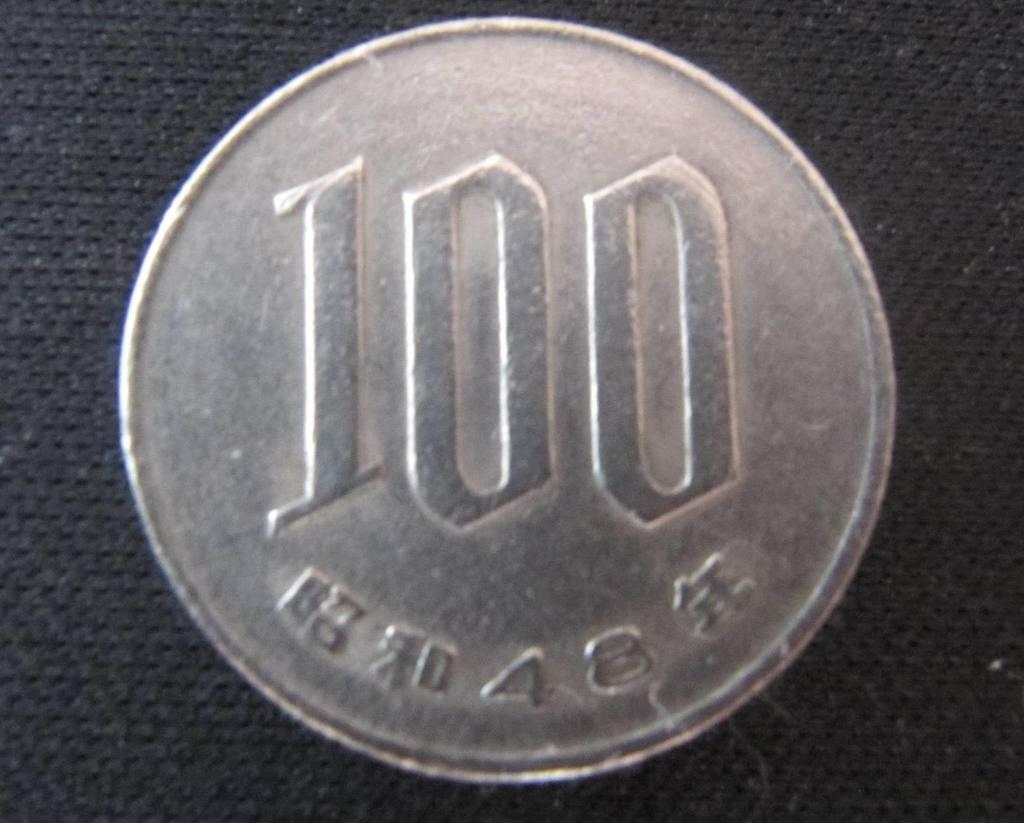<image>
Create a compact narrative representing the image presented. a silver coin with 100 written largely across the middle of it 